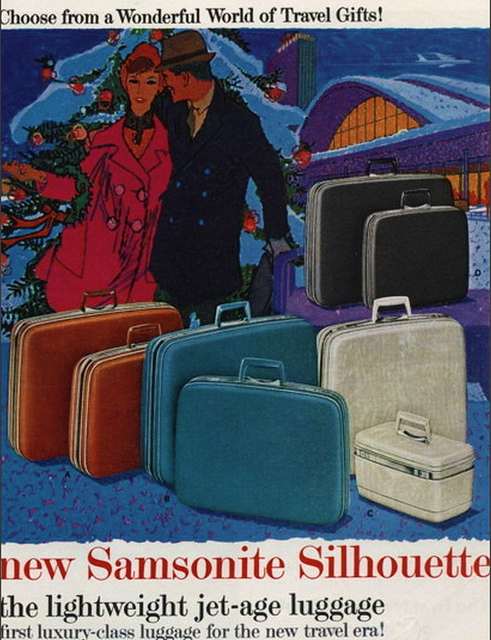Please transcribe the text information in this image. Choose from a Wonderful World of era travel new the for luggage class luxury first luggage -age jet lightweight the Silhouette Samsonite new Gifts! Travel 